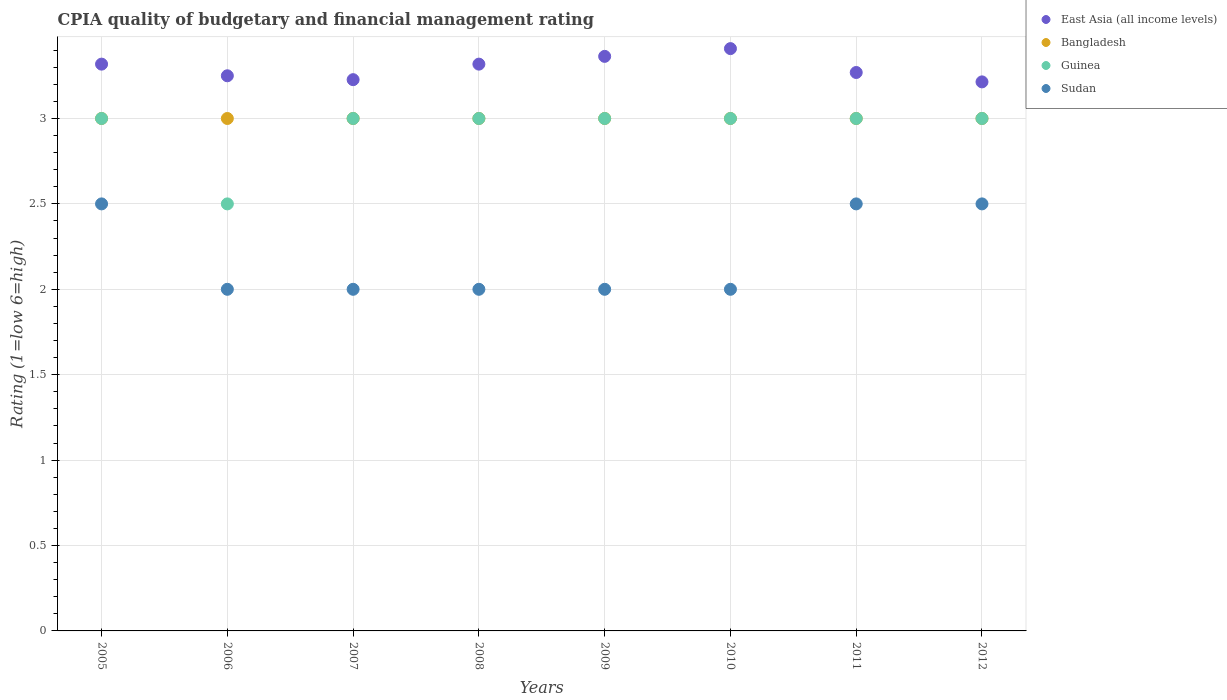How many different coloured dotlines are there?
Keep it short and to the point. 4. Is the number of dotlines equal to the number of legend labels?
Offer a terse response. Yes. What is the CPIA rating in Sudan in 2012?
Ensure brevity in your answer.  2.5. Across all years, what is the maximum CPIA rating in Bangladesh?
Ensure brevity in your answer.  3. Across all years, what is the minimum CPIA rating in Guinea?
Offer a terse response. 2.5. What is the difference between the CPIA rating in East Asia (all income levels) in 2005 and that in 2008?
Give a very brief answer. 0. What is the average CPIA rating in Guinea per year?
Make the answer very short. 2.94. In the year 2007, what is the difference between the CPIA rating in Bangladesh and CPIA rating in East Asia (all income levels)?
Your answer should be very brief. -0.23. What is the ratio of the CPIA rating in Bangladesh in 2007 to that in 2011?
Keep it short and to the point. 1. Is the difference between the CPIA rating in Bangladesh in 2005 and 2007 greater than the difference between the CPIA rating in East Asia (all income levels) in 2005 and 2007?
Your answer should be compact. No. What is the difference between the highest and the lowest CPIA rating in East Asia (all income levels)?
Your answer should be very brief. 0.19. In how many years, is the CPIA rating in Guinea greater than the average CPIA rating in Guinea taken over all years?
Give a very brief answer. 7. Is the sum of the CPIA rating in Sudan in 2007 and 2008 greater than the maximum CPIA rating in Bangladesh across all years?
Your response must be concise. Yes. Is it the case that in every year, the sum of the CPIA rating in Sudan and CPIA rating in East Asia (all income levels)  is greater than the sum of CPIA rating in Bangladesh and CPIA rating in Guinea?
Offer a terse response. No. Is it the case that in every year, the sum of the CPIA rating in East Asia (all income levels) and CPIA rating in Sudan  is greater than the CPIA rating in Guinea?
Keep it short and to the point. Yes. Does the graph contain grids?
Ensure brevity in your answer.  Yes. Where does the legend appear in the graph?
Your response must be concise. Top right. How many legend labels are there?
Your response must be concise. 4. What is the title of the graph?
Keep it short and to the point. CPIA quality of budgetary and financial management rating. Does "Cameroon" appear as one of the legend labels in the graph?
Make the answer very short. No. What is the Rating (1=low 6=high) in East Asia (all income levels) in 2005?
Make the answer very short. 3.32. What is the Rating (1=low 6=high) of Bangladesh in 2005?
Give a very brief answer. 3. What is the Rating (1=low 6=high) of Guinea in 2005?
Offer a terse response. 3. What is the Rating (1=low 6=high) in Bangladesh in 2006?
Provide a succinct answer. 3. What is the Rating (1=low 6=high) of Guinea in 2006?
Make the answer very short. 2.5. What is the Rating (1=low 6=high) in Sudan in 2006?
Your response must be concise. 2. What is the Rating (1=low 6=high) in East Asia (all income levels) in 2007?
Offer a terse response. 3.23. What is the Rating (1=low 6=high) in Bangladesh in 2007?
Make the answer very short. 3. What is the Rating (1=low 6=high) in East Asia (all income levels) in 2008?
Offer a terse response. 3.32. What is the Rating (1=low 6=high) of Bangladesh in 2008?
Give a very brief answer. 3. What is the Rating (1=low 6=high) of East Asia (all income levels) in 2009?
Your answer should be very brief. 3.36. What is the Rating (1=low 6=high) in Guinea in 2009?
Provide a short and direct response. 3. What is the Rating (1=low 6=high) in Sudan in 2009?
Your answer should be very brief. 2. What is the Rating (1=low 6=high) of East Asia (all income levels) in 2010?
Make the answer very short. 3.41. What is the Rating (1=low 6=high) in Guinea in 2010?
Provide a short and direct response. 3. What is the Rating (1=low 6=high) of East Asia (all income levels) in 2011?
Offer a very short reply. 3.27. What is the Rating (1=low 6=high) of East Asia (all income levels) in 2012?
Make the answer very short. 3.21. What is the Rating (1=low 6=high) in Guinea in 2012?
Your response must be concise. 3. Across all years, what is the maximum Rating (1=low 6=high) of East Asia (all income levels)?
Offer a terse response. 3.41. Across all years, what is the maximum Rating (1=low 6=high) in Sudan?
Your response must be concise. 2.5. Across all years, what is the minimum Rating (1=low 6=high) in East Asia (all income levels)?
Ensure brevity in your answer.  3.21. Across all years, what is the minimum Rating (1=low 6=high) in Bangladesh?
Your answer should be very brief. 3. Across all years, what is the minimum Rating (1=low 6=high) of Guinea?
Make the answer very short. 2.5. What is the total Rating (1=low 6=high) in East Asia (all income levels) in the graph?
Make the answer very short. 26.37. What is the total Rating (1=low 6=high) in Guinea in the graph?
Offer a very short reply. 23.5. What is the total Rating (1=low 6=high) in Sudan in the graph?
Offer a very short reply. 17.5. What is the difference between the Rating (1=low 6=high) of East Asia (all income levels) in 2005 and that in 2006?
Offer a terse response. 0.07. What is the difference between the Rating (1=low 6=high) in East Asia (all income levels) in 2005 and that in 2007?
Your answer should be very brief. 0.09. What is the difference between the Rating (1=low 6=high) of Bangladesh in 2005 and that in 2007?
Make the answer very short. 0. What is the difference between the Rating (1=low 6=high) of Sudan in 2005 and that in 2007?
Provide a succinct answer. 0.5. What is the difference between the Rating (1=low 6=high) of East Asia (all income levels) in 2005 and that in 2008?
Your answer should be very brief. 0. What is the difference between the Rating (1=low 6=high) in Sudan in 2005 and that in 2008?
Your response must be concise. 0.5. What is the difference between the Rating (1=low 6=high) of East Asia (all income levels) in 2005 and that in 2009?
Make the answer very short. -0.05. What is the difference between the Rating (1=low 6=high) in Sudan in 2005 and that in 2009?
Give a very brief answer. 0.5. What is the difference between the Rating (1=low 6=high) of East Asia (all income levels) in 2005 and that in 2010?
Offer a very short reply. -0.09. What is the difference between the Rating (1=low 6=high) of Bangladesh in 2005 and that in 2010?
Your answer should be very brief. 0. What is the difference between the Rating (1=low 6=high) of Guinea in 2005 and that in 2010?
Offer a very short reply. 0. What is the difference between the Rating (1=low 6=high) in Sudan in 2005 and that in 2010?
Offer a terse response. 0.5. What is the difference between the Rating (1=low 6=high) in East Asia (all income levels) in 2005 and that in 2011?
Your answer should be compact. 0.05. What is the difference between the Rating (1=low 6=high) of Guinea in 2005 and that in 2011?
Give a very brief answer. 0. What is the difference between the Rating (1=low 6=high) of East Asia (all income levels) in 2005 and that in 2012?
Your response must be concise. 0.1. What is the difference between the Rating (1=low 6=high) in Guinea in 2005 and that in 2012?
Make the answer very short. 0. What is the difference between the Rating (1=low 6=high) in Sudan in 2005 and that in 2012?
Offer a terse response. 0. What is the difference between the Rating (1=low 6=high) in East Asia (all income levels) in 2006 and that in 2007?
Keep it short and to the point. 0.02. What is the difference between the Rating (1=low 6=high) in Guinea in 2006 and that in 2007?
Provide a short and direct response. -0.5. What is the difference between the Rating (1=low 6=high) in East Asia (all income levels) in 2006 and that in 2008?
Give a very brief answer. -0.07. What is the difference between the Rating (1=low 6=high) of Bangladesh in 2006 and that in 2008?
Give a very brief answer. 0. What is the difference between the Rating (1=low 6=high) of Guinea in 2006 and that in 2008?
Provide a short and direct response. -0.5. What is the difference between the Rating (1=low 6=high) in East Asia (all income levels) in 2006 and that in 2009?
Offer a terse response. -0.11. What is the difference between the Rating (1=low 6=high) of Guinea in 2006 and that in 2009?
Provide a short and direct response. -0.5. What is the difference between the Rating (1=low 6=high) in East Asia (all income levels) in 2006 and that in 2010?
Ensure brevity in your answer.  -0.16. What is the difference between the Rating (1=low 6=high) of Bangladesh in 2006 and that in 2010?
Provide a short and direct response. 0. What is the difference between the Rating (1=low 6=high) in Guinea in 2006 and that in 2010?
Offer a terse response. -0.5. What is the difference between the Rating (1=low 6=high) in Sudan in 2006 and that in 2010?
Your answer should be compact. 0. What is the difference between the Rating (1=low 6=high) of East Asia (all income levels) in 2006 and that in 2011?
Provide a succinct answer. -0.02. What is the difference between the Rating (1=low 6=high) in Guinea in 2006 and that in 2011?
Provide a short and direct response. -0.5. What is the difference between the Rating (1=low 6=high) in East Asia (all income levels) in 2006 and that in 2012?
Provide a succinct answer. 0.04. What is the difference between the Rating (1=low 6=high) of Bangladesh in 2006 and that in 2012?
Your answer should be very brief. 0. What is the difference between the Rating (1=low 6=high) of Guinea in 2006 and that in 2012?
Provide a short and direct response. -0.5. What is the difference between the Rating (1=low 6=high) of Sudan in 2006 and that in 2012?
Give a very brief answer. -0.5. What is the difference between the Rating (1=low 6=high) of East Asia (all income levels) in 2007 and that in 2008?
Provide a short and direct response. -0.09. What is the difference between the Rating (1=low 6=high) in Bangladesh in 2007 and that in 2008?
Offer a terse response. 0. What is the difference between the Rating (1=low 6=high) in Sudan in 2007 and that in 2008?
Your answer should be compact. 0. What is the difference between the Rating (1=low 6=high) of East Asia (all income levels) in 2007 and that in 2009?
Make the answer very short. -0.14. What is the difference between the Rating (1=low 6=high) in Bangladesh in 2007 and that in 2009?
Your answer should be compact. 0. What is the difference between the Rating (1=low 6=high) of East Asia (all income levels) in 2007 and that in 2010?
Offer a very short reply. -0.18. What is the difference between the Rating (1=low 6=high) of Sudan in 2007 and that in 2010?
Ensure brevity in your answer.  0. What is the difference between the Rating (1=low 6=high) of East Asia (all income levels) in 2007 and that in 2011?
Provide a succinct answer. -0.04. What is the difference between the Rating (1=low 6=high) in Guinea in 2007 and that in 2011?
Your answer should be compact. 0. What is the difference between the Rating (1=low 6=high) of Sudan in 2007 and that in 2011?
Make the answer very short. -0.5. What is the difference between the Rating (1=low 6=high) in East Asia (all income levels) in 2007 and that in 2012?
Your response must be concise. 0.01. What is the difference between the Rating (1=low 6=high) of Bangladesh in 2007 and that in 2012?
Keep it short and to the point. 0. What is the difference between the Rating (1=low 6=high) in East Asia (all income levels) in 2008 and that in 2009?
Your response must be concise. -0.05. What is the difference between the Rating (1=low 6=high) in Bangladesh in 2008 and that in 2009?
Your answer should be compact. 0. What is the difference between the Rating (1=low 6=high) of East Asia (all income levels) in 2008 and that in 2010?
Your answer should be compact. -0.09. What is the difference between the Rating (1=low 6=high) in Guinea in 2008 and that in 2010?
Keep it short and to the point. 0. What is the difference between the Rating (1=low 6=high) of Sudan in 2008 and that in 2010?
Offer a terse response. 0. What is the difference between the Rating (1=low 6=high) in East Asia (all income levels) in 2008 and that in 2011?
Offer a very short reply. 0.05. What is the difference between the Rating (1=low 6=high) of Bangladesh in 2008 and that in 2011?
Offer a terse response. 0. What is the difference between the Rating (1=low 6=high) in Sudan in 2008 and that in 2011?
Your answer should be compact. -0.5. What is the difference between the Rating (1=low 6=high) of East Asia (all income levels) in 2008 and that in 2012?
Your answer should be compact. 0.1. What is the difference between the Rating (1=low 6=high) in East Asia (all income levels) in 2009 and that in 2010?
Make the answer very short. -0.05. What is the difference between the Rating (1=low 6=high) of Guinea in 2009 and that in 2010?
Make the answer very short. 0. What is the difference between the Rating (1=low 6=high) in Sudan in 2009 and that in 2010?
Provide a succinct answer. 0. What is the difference between the Rating (1=low 6=high) of East Asia (all income levels) in 2009 and that in 2011?
Provide a succinct answer. 0.09. What is the difference between the Rating (1=low 6=high) of Bangladesh in 2009 and that in 2011?
Offer a very short reply. 0. What is the difference between the Rating (1=low 6=high) in East Asia (all income levels) in 2009 and that in 2012?
Provide a succinct answer. 0.15. What is the difference between the Rating (1=low 6=high) in Bangladesh in 2009 and that in 2012?
Offer a terse response. 0. What is the difference between the Rating (1=low 6=high) in Sudan in 2009 and that in 2012?
Provide a succinct answer. -0.5. What is the difference between the Rating (1=low 6=high) in East Asia (all income levels) in 2010 and that in 2011?
Ensure brevity in your answer.  0.14. What is the difference between the Rating (1=low 6=high) of Bangladesh in 2010 and that in 2011?
Ensure brevity in your answer.  0. What is the difference between the Rating (1=low 6=high) in Guinea in 2010 and that in 2011?
Provide a succinct answer. 0. What is the difference between the Rating (1=low 6=high) of East Asia (all income levels) in 2010 and that in 2012?
Offer a very short reply. 0.19. What is the difference between the Rating (1=low 6=high) in Bangladesh in 2010 and that in 2012?
Provide a short and direct response. 0. What is the difference between the Rating (1=low 6=high) of Guinea in 2010 and that in 2012?
Your response must be concise. 0. What is the difference between the Rating (1=low 6=high) in Sudan in 2010 and that in 2012?
Your response must be concise. -0.5. What is the difference between the Rating (1=low 6=high) of East Asia (all income levels) in 2011 and that in 2012?
Make the answer very short. 0.05. What is the difference between the Rating (1=low 6=high) of Guinea in 2011 and that in 2012?
Give a very brief answer. 0. What is the difference between the Rating (1=low 6=high) in East Asia (all income levels) in 2005 and the Rating (1=low 6=high) in Bangladesh in 2006?
Provide a succinct answer. 0.32. What is the difference between the Rating (1=low 6=high) of East Asia (all income levels) in 2005 and the Rating (1=low 6=high) of Guinea in 2006?
Your answer should be very brief. 0.82. What is the difference between the Rating (1=low 6=high) in East Asia (all income levels) in 2005 and the Rating (1=low 6=high) in Sudan in 2006?
Make the answer very short. 1.32. What is the difference between the Rating (1=low 6=high) of Bangladesh in 2005 and the Rating (1=low 6=high) of Sudan in 2006?
Give a very brief answer. 1. What is the difference between the Rating (1=low 6=high) of Guinea in 2005 and the Rating (1=low 6=high) of Sudan in 2006?
Provide a succinct answer. 1. What is the difference between the Rating (1=low 6=high) in East Asia (all income levels) in 2005 and the Rating (1=low 6=high) in Bangladesh in 2007?
Keep it short and to the point. 0.32. What is the difference between the Rating (1=low 6=high) of East Asia (all income levels) in 2005 and the Rating (1=low 6=high) of Guinea in 2007?
Provide a succinct answer. 0.32. What is the difference between the Rating (1=low 6=high) in East Asia (all income levels) in 2005 and the Rating (1=low 6=high) in Sudan in 2007?
Your answer should be very brief. 1.32. What is the difference between the Rating (1=low 6=high) of Bangladesh in 2005 and the Rating (1=low 6=high) of Guinea in 2007?
Provide a succinct answer. 0. What is the difference between the Rating (1=low 6=high) of Guinea in 2005 and the Rating (1=low 6=high) of Sudan in 2007?
Ensure brevity in your answer.  1. What is the difference between the Rating (1=low 6=high) in East Asia (all income levels) in 2005 and the Rating (1=low 6=high) in Bangladesh in 2008?
Ensure brevity in your answer.  0.32. What is the difference between the Rating (1=low 6=high) of East Asia (all income levels) in 2005 and the Rating (1=low 6=high) of Guinea in 2008?
Give a very brief answer. 0.32. What is the difference between the Rating (1=low 6=high) of East Asia (all income levels) in 2005 and the Rating (1=low 6=high) of Sudan in 2008?
Give a very brief answer. 1.32. What is the difference between the Rating (1=low 6=high) in Bangladesh in 2005 and the Rating (1=low 6=high) in Sudan in 2008?
Keep it short and to the point. 1. What is the difference between the Rating (1=low 6=high) of East Asia (all income levels) in 2005 and the Rating (1=low 6=high) of Bangladesh in 2009?
Ensure brevity in your answer.  0.32. What is the difference between the Rating (1=low 6=high) of East Asia (all income levels) in 2005 and the Rating (1=low 6=high) of Guinea in 2009?
Your answer should be very brief. 0.32. What is the difference between the Rating (1=low 6=high) in East Asia (all income levels) in 2005 and the Rating (1=low 6=high) in Sudan in 2009?
Your response must be concise. 1.32. What is the difference between the Rating (1=low 6=high) in Bangladesh in 2005 and the Rating (1=low 6=high) in Guinea in 2009?
Make the answer very short. 0. What is the difference between the Rating (1=low 6=high) in Bangladesh in 2005 and the Rating (1=low 6=high) in Sudan in 2009?
Your answer should be very brief. 1. What is the difference between the Rating (1=low 6=high) of East Asia (all income levels) in 2005 and the Rating (1=low 6=high) of Bangladesh in 2010?
Your response must be concise. 0.32. What is the difference between the Rating (1=low 6=high) of East Asia (all income levels) in 2005 and the Rating (1=low 6=high) of Guinea in 2010?
Offer a terse response. 0.32. What is the difference between the Rating (1=low 6=high) of East Asia (all income levels) in 2005 and the Rating (1=low 6=high) of Sudan in 2010?
Provide a short and direct response. 1.32. What is the difference between the Rating (1=low 6=high) of Bangladesh in 2005 and the Rating (1=low 6=high) of Guinea in 2010?
Ensure brevity in your answer.  0. What is the difference between the Rating (1=low 6=high) of Bangladesh in 2005 and the Rating (1=low 6=high) of Sudan in 2010?
Your answer should be very brief. 1. What is the difference between the Rating (1=low 6=high) in East Asia (all income levels) in 2005 and the Rating (1=low 6=high) in Bangladesh in 2011?
Provide a short and direct response. 0.32. What is the difference between the Rating (1=low 6=high) of East Asia (all income levels) in 2005 and the Rating (1=low 6=high) of Guinea in 2011?
Your response must be concise. 0.32. What is the difference between the Rating (1=low 6=high) of East Asia (all income levels) in 2005 and the Rating (1=low 6=high) of Sudan in 2011?
Make the answer very short. 0.82. What is the difference between the Rating (1=low 6=high) of Bangladesh in 2005 and the Rating (1=low 6=high) of Sudan in 2011?
Offer a very short reply. 0.5. What is the difference between the Rating (1=low 6=high) in East Asia (all income levels) in 2005 and the Rating (1=low 6=high) in Bangladesh in 2012?
Offer a terse response. 0.32. What is the difference between the Rating (1=low 6=high) in East Asia (all income levels) in 2005 and the Rating (1=low 6=high) in Guinea in 2012?
Provide a short and direct response. 0.32. What is the difference between the Rating (1=low 6=high) of East Asia (all income levels) in 2005 and the Rating (1=low 6=high) of Sudan in 2012?
Provide a succinct answer. 0.82. What is the difference between the Rating (1=low 6=high) of Bangladesh in 2005 and the Rating (1=low 6=high) of Sudan in 2012?
Your answer should be compact. 0.5. What is the difference between the Rating (1=low 6=high) in East Asia (all income levels) in 2006 and the Rating (1=low 6=high) in Bangladesh in 2007?
Your response must be concise. 0.25. What is the difference between the Rating (1=low 6=high) of East Asia (all income levels) in 2006 and the Rating (1=low 6=high) of Guinea in 2007?
Offer a terse response. 0.25. What is the difference between the Rating (1=low 6=high) of East Asia (all income levels) in 2006 and the Rating (1=low 6=high) of Sudan in 2007?
Keep it short and to the point. 1.25. What is the difference between the Rating (1=low 6=high) of Bangladesh in 2006 and the Rating (1=low 6=high) of Guinea in 2007?
Give a very brief answer. 0. What is the difference between the Rating (1=low 6=high) of East Asia (all income levels) in 2006 and the Rating (1=low 6=high) of Bangladesh in 2008?
Provide a succinct answer. 0.25. What is the difference between the Rating (1=low 6=high) of East Asia (all income levels) in 2006 and the Rating (1=low 6=high) of Guinea in 2008?
Offer a very short reply. 0.25. What is the difference between the Rating (1=low 6=high) in East Asia (all income levels) in 2006 and the Rating (1=low 6=high) in Sudan in 2008?
Make the answer very short. 1.25. What is the difference between the Rating (1=low 6=high) of Bangladesh in 2006 and the Rating (1=low 6=high) of Guinea in 2008?
Your answer should be compact. 0. What is the difference between the Rating (1=low 6=high) in Bangladesh in 2006 and the Rating (1=low 6=high) in Sudan in 2008?
Offer a terse response. 1. What is the difference between the Rating (1=low 6=high) of Guinea in 2006 and the Rating (1=low 6=high) of Sudan in 2008?
Make the answer very short. 0.5. What is the difference between the Rating (1=low 6=high) of East Asia (all income levels) in 2006 and the Rating (1=low 6=high) of Bangladesh in 2009?
Give a very brief answer. 0.25. What is the difference between the Rating (1=low 6=high) in East Asia (all income levels) in 2006 and the Rating (1=low 6=high) in Guinea in 2009?
Your answer should be very brief. 0.25. What is the difference between the Rating (1=low 6=high) of Bangladesh in 2006 and the Rating (1=low 6=high) of Sudan in 2009?
Provide a succinct answer. 1. What is the difference between the Rating (1=low 6=high) of Guinea in 2006 and the Rating (1=low 6=high) of Sudan in 2009?
Ensure brevity in your answer.  0.5. What is the difference between the Rating (1=low 6=high) of East Asia (all income levels) in 2006 and the Rating (1=low 6=high) of Guinea in 2010?
Your answer should be compact. 0.25. What is the difference between the Rating (1=low 6=high) in Bangladesh in 2006 and the Rating (1=low 6=high) in Guinea in 2010?
Give a very brief answer. 0. What is the difference between the Rating (1=low 6=high) in Bangladesh in 2006 and the Rating (1=low 6=high) in Sudan in 2010?
Give a very brief answer. 1. What is the difference between the Rating (1=low 6=high) of Guinea in 2006 and the Rating (1=low 6=high) of Sudan in 2010?
Your answer should be very brief. 0.5. What is the difference between the Rating (1=low 6=high) of East Asia (all income levels) in 2006 and the Rating (1=low 6=high) of Bangladesh in 2011?
Your answer should be very brief. 0.25. What is the difference between the Rating (1=low 6=high) of Bangladesh in 2006 and the Rating (1=low 6=high) of Sudan in 2011?
Give a very brief answer. 0.5. What is the difference between the Rating (1=low 6=high) in Guinea in 2006 and the Rating (1=low 6=high) in Sudan in 2011?
Offer a terse response. 0. What is the difference between the Rating (1=low 6=high) in East Asia (all income levels) in 2006 and the Rating (1=low 6=high) in Guinea in 2012?
Your answer should be compact. 0.25. What is the difference between the Rating (1=low 6=high) in Bangladesh in 2006 and the Rating (1=low 6=high) in Guinea in 2012?
Make the answer very short. 0. What is the difference between the Rating (1=low 6=high) in Bangladesh in 2006 and the Rating (1=low 6=high) in Sudan in 2012?
Provide a short and direct response. 0.5. What is the difference between the Rating (1=low 6=high) in East Asia (all income levels) in 2007 and the Rating (1=low 6=high) in Bangladesh in 2008?
Offer a very short reply. 0.23. What is the difference between the Rating (1=low 6=high) of East Asia (all income levels) in 2007 and the Rating (1=low 6=high) of Guinea in 2008?
Make the answer very short. 0.23. What is the difference between the Rating (1=low 6=high) in East Asia (all income levels) in 2007 and the Rating (1=low 6=high) in Sudan in 2008?
Keep it short and to the point. 1.23. What is the difference between the Rating (1=low 6=high) in Bangladesh in 2007 and the Rating (1=low 6=high) in Guinea in 2008?
Offer a terse response. 0. What is the difference between the Rating (1=low 6=high) of Guinea in 2007 and the Rating (1=low 6=high) of Sudan in 2008?
Ensure brevity in your answer.  1. What is the difference between the Rating (1=low 6=high) of East Asia (all income levels) in 2007 and the Rating (1=low 6=high) of Bangladesh in 2009?
Your answer should be very brief. 0.23. What is the difference between the Rating (1=low 6=high) of East Asia (all income levels) in 2007 and the Rating (1=low 6=high) of Guinea in 2009?
Provide a short and direct response. 0.23. What is the difference between the Rating (1=low 6=high) of East Asia (all income levels) in 2007 and the Rating (1=low 6=high) of Sudan in 2009?
Provide a short and direct response. 1.23. What is the difference between the Rating (1=low 6=high) of Bangladesh in 2007 and the Rating (1=low 6=high) of Guinea in 2009?
Provide a short and direct response. 0. What is the difference between the Rating (1=low 6=high) of Guinea in 2007 and the Rating (1=low 6=high) of Sudan in 2009?
Your answer should be compact. 1. What is the difference between the Rating (1=low 6=high) in East Asia (all income levels) in 2007 and the Rating (1=low 6=high) in Bangladesh in 2010?
Provide a succinct answer. 0.23. What is the difference between the Rating (1=low 6=high) of East Asia (all income levels) in 2007 and the Rating (1=low 6=high) of Guinea in 2010?
Keep it short and to the point. 0.23. What is the difference between the Rating (1=low 6=high) in East Asia (all income levels) in 2007 and the Rating (1=low 6=high) in Sudan in 2010?
Provide a short and direct response. 1.23. What is the difference between the Rating (1=low 6=high) in Guinea in 2007 and the Rating (1=low 6=high) in Sudan in 2010?
Give a very brief answer. 1. What is the difference between the Rating (1=low 6=high) in East Asia (all income levels) in 2007 and the Rating (1=low 6=high) in Bangladesh in 2011?
Your response must be concise. 0.23. What is the difference between the Rating (1=low 6=high) of East Asia (all income levels) in 2007 and the Rating (1=low 6=high) of Guinea in 2011?
Make the answer very short. 0.23. What is the difference between the Rating (1=low 6=high) in East Asia (all income levels) in 2007 and the Rating (1=low 6=high) in Sudan in 2011?
Your answer should be compact. 0.73. What is the difference between the Rating (1=low 6=high) in East Asia (all income levels) in 2007 and the Rating (1=low 6=high) in Bangladesh in 2012?
Your response must be concise. 0.23. What is the difference between the Rating (1=low 6=high) of East Asia (all income levels) in 2007 and the Rating (1=low 6=high) of Guinea in 2012?
Provide a short and direct response. 0.23. What is the difference between the Rating (1=low 6=high) in East Asia (all income levels) in 2007 and the Rating (1=low 6=high) in Sudan in 2012?
Give a very brief answer. 0.73. What is the difference between the Rating (1=low 6=high) of Bangladesh in 2007 and the Rating (1=low 6=high) of Guinea in 2012?
Give a very brief answer. 0. What is the difference between the Rating (1=low 6=high) of Bangladesh in 2007 and the Rating (1=low 6=high) of Sudan in 2012?
Give a very brief answer. 0.5. What is the difference between the Rating (1=low 6=high) in Guinea in 2007 and the Rating (1=low 6=high) in Sudan in 2012?
Your answer should be very brief. 0.5. What is the difference between the Rating (1=low 6=high) of East Asia (all income levels) in 2008 and the Rating (1=low 6=high) of Bangladesh in 2009?
Make the answer very short. 0.32. What is the difference between the Rating (1=low 6=high) in East Asia (all income levels) in 2008 and the Rating (1=low 6=high) in Guinea in 2009?
Make the answer very short. 0.32. What is the difference between the Rating (1=low 6=high) in East Asia (all income levels) in 2008 and the Rating (1=low 6=high) in Sudan in 2009?
Your answer should be compact. 1.32. What is the difference between the Rating (1=low 6=high) in Bangladesh in 2008 and the Rating (1=low 6=high) in Guinea in 2009?
Ensure brevity in your answer.  0. What is the difference between the Rating (1=low 6=high) of Bangladesh in 2008 and the Rating (1=low 6=high) of Sudan in 2009?
Offer a terse response. 1. What is the difference between the Rating (1=low 6=high) in Guinea in 2008 and the Rating (1=low 6=high) in Sudan in 2009?
Offer a terse response. 1. What is the difference between the Rating (1=low 6=high) in East Asia (all income levels) in 2008 and the Rating (1=low 6=high) in Bangladesh in 2010?
Offer a terse response. 0.32. What is the difference between the Rating (1=low 6=high) in East Asia (all income levels) in 2008 and the Rating (1=low 6=high) in Guinea in 2010?
Keep it short and to the point. 0.32. What is the difference between the Rating (1=low 6=high) in East Asia (all income levels) in 2008 and the Rating (1=low 6=high) in Sudan in 2010?
Give a very brief answer. 1.32. What is the difference between the Rating (1=low 6=high) of Bangladesh in 2008 and the Rating (1=low 6=high) of Sudan in 2010?
Offer a terse response. 1. What is the difference between the Rating (1=low 6=high) of Guinea in 2008 and the Rating (1=low 6=high) of Sudan in 2010?
Ensure brevity in your answer.  1. What is the difference between the Rating (1=low 6=high) of East Asia (all income levels) in 2008 and the Rating (1=low 6=high) of Bangladesh in 2011?
Provide a succinct answer. 0.32. What is the difference between the Rating (1=low 6=high) of East Asia (all income levels) in 2008 and the Rating (1=low 6=high) of Guinea in 2011?
Your answer should be very brief. 0.32. What is the difference between the Rating (1=low 6=high) of East Asia (all income levels) in 2008 and the Rating (1=low 6=high) of Sudan in 2011?
Offer a very short reply. 0.82. What is the difference between the Rating (1=low 6=high) in Bangladesh in 2008 and the Rating (1=low 6=high) in Guinea in 2011?
Make the answer very short. 0. What is the difference between the Rating (1=low 6=high) in Guinea in 2008 and the Rating (1=low 6=high) in Sudan in 2011?
Keep it short and to the point. 0.5. What is the difference between the Rating (1=low 6=high) in East Asia (all income levels) in 2008 and the Rating (1=low 6=high) in Bangladesh in 2012?
Offer a very short reply. 0.32. What is the difference between the Rating (1=low 6=high) of East Asia (all income levels) in 2008 and the Rating (1=low 6=high) of Guinea in 2012?
Your answer should be compact. 0.32. What is the difference between the Rating (1=low 6=high) of East Asia (all income levels) in 2008 and the Rating (1=low 6=high) of Sudan in 2012?
Your answer should be compact. 0.82. What is the difference between the Rating (1=low 6=high) in East Asia (all income levels) in 2009 and the Rating (1=low 6=high) in Bangladesh in 2010?
Offer a terse response. 0.36. What is the difference between the Rating (1=low 6=high) in East Asia (all income levels) in 2009 and the Rating (1=low 6=high) in Guinea in 2010?
Offer a very short reply. 0.36. What is the difference between the Rating (1=low 6=high) of East Asia (all income levels) in 2009 and the Rating (1=low 6=high) of Sudan in 2010?
Ensure brevity in your answer.  1.36. What is the difference between the Rating (1=low 6=high) of Bangladesh in 2009 and the Rating (1=low 6=high) of Sudan in 2010?
Make the answer very short. 1. What is the difference between the Rating (1=low 6=high) of East Asia (all income levels) in 2009 and the Rating (1=low 6=high) of Bangladesh in 2011?
Provide a succinct answer. 0.36. What is the difference between the Rating (1=low 6=high) in East Asia (all income levels) in 2009 and the Rating (1=low 6=high) in Guinea in 2011?
Offer a terse response. 0.36. What is the difference between the Rating (1=low 6=high) of East Asia (all income levels) in 2009 and the Rating (1=low 6=high) of Sudan in 2011?
Keep it short and to the point. 0.86. What is the difference between the Rating (1=low 6=high) of Bangladesh in 2009 and the Rating (1=low 6=high) of Sudan in 2011?
Your response must be concise. 0.5. What is the difference between the Rating (1=low 6=high) in East Asia (all income levels) in 2009 and the Rating (1=low 6=high) in Bangladesh in 2012?
Offer a very short reply. 0.36. What is the difference between the Rating (1=low 6=high) of East Asia (all income levels) in 2009 and the Rating (1=low 6=high) of Guinea in 2012?
Give a very brief answer. 0.36. What is the difference between the Rating (1=low 6=high) of East Asia (all income levels) in 2009 and the Rating (1=low 6=high) of Sudan in 2012?
Ensure brevity in your answer.  0.86. What is the difference between the Rating (1=low 6=high) of Bangladesh in 2009 and the Rating (1=low 6=high) of Sudan in 2012?
Your answer should be very brief. 0.5. What is the difference between the Rating (1=low 6=high) in Guinea in 2009 and the Rating (1=low 6=high) in Sudan in 2012?
Ensure brevity in your answer.  0.5. What is the difference between the Rating (1=low 6=high) in East Asia (all income levels) in 2010 and the Rating (1=low 6=high) in Bangladesh in 2011?
Provide a short and direct response. 0.41. What is the difference between the Rating (1=low 6=high) in East Asia (all income levels) in 2010 and the Rating (1=low 6=high) in Guinea in 2011?
Your answer should be very brief. 0.41. What is the difference between the Rating (1=low 6=high) of East Asia (all income levels) in 2010 and the Rating (1=low 6=high) of Bangladesh in 2012?
Your answer should be compact. 0.41. What is the difference between the Rating (1=low 6=high) in East Asia (all income levels) in 2010 and the Rating (1=low 6=high) in Guinea in 2012?
Give a very brief answer. 0.41. What is the difference between the Rating (1=low 6=high) in Bangladesh in 2010 and the Rating (1=low 6=high) in Guinea in 2012?
Offer a terse response. 0. What is the difference between the Rating (1=low 6=high) of Bangladesh in 2010 and the Rating (1=low 6=high) of Sudan in 2012?
Provide a succinct answer. 0.5. What is the difference between the Rating (1=low 6=high) in East Asia (all income levels) in 2011 and the Rating (1=low 6=high) in Bangladesh in 2012?
Ensure brevity in your answer.  0.27. What is the difference between the Rating (1=low 6=high) in East Asia (all income levels) in 2011 and the Rating (1=low 6=high) in Guinea in 2012?
Make the answer very short. 0.27. What is the difference between the Rating (1=low 6=high) in East Asia (all income levels) in 2011 and the Rating (1=low 6=high) in Sudan in 2012?
Make the answer very short. 0.77. What is the difference between the Rating (1=low 6=high) of Bangladesh in 2011 and the Rating (1=low 6=high) of Guinea in 2012?
Offer a very short reply. 0. What is the difference between the Rating (1=low 6=high) of Guinea in 2011 and the Rating (1=low 6=high) of Sudan in 2012?
Your answer should be very brief. 0.5. What is the average Rating (1=low 6=high) of East Asia (all income levels) per year?
Your answer should be compact. 3.3. What is the average Rating (1=low 6=high) in Guinea per year?
Your response must be concise. 2.94. What is the average Rating (1=low 6=high) of Sudan per year?
Keep it short and to the point. 2.19. In the year 2005, what is the difference between the Rating (1=low 6=high) in East Asia (all income levels) and Rating (1=low 6=high) in Bangladesh?
Your response must be concise. 0.32. In the year 2005, what is the difference between the Rating (1=low 6=high) of East Asia (all income levels) and Rating (1=low 6=high) of Guinea?
Make the answer very short. 0.32. In the year 2005, what is the difference between the Rating (1=low 6=high) of East Asia (all income levels) and Rating (1=low 6=high) of Sudan?
Offer a terse response. 0.82. In the year 2005, what is the difference between the Rating (1=low 6=high) in Bangladesh and Rating (1=low 6=high) in Sudan?
Ensure brevity in your answer.  0.5. In the year 2005, what is the difference between the Rating (1=low 6=high) in Guinea and Rating (1=low 6=high) in Sudan?
Offer a terse response. 0.5. In the year 2006, what is the difference between the Rating (1=low 6=high) in East Asia (all income levels) and Rating (1=low 6=high) in Bangladesh?
Provide a succinct answer. 0.25. In the year 2006, what is the difference between the Rating (1=low 6=high) in East Asia (all income levels) and Rating (1=low 6=high) in Guinea?
Provide a short and direct response. 0.75. In the year 2006, what is the difference between the Rating (1=low 6=high) of East Asia (all income levels) and Rating (1=low 6=high) of Sudan?
Your response must be concise. 1.25. In the year 2006, what is the difference between the Rating (1=low 6=high) in Guinea and Rating (1=low 6=high) in Sudan?
Ensure brevity in your answer.  0.5. In the year 2007, what is the difference between the Rating (1=low 6=high) of East Asia (all income levels) and Rating (1=low 6=high) of Bangladesh?
Your response must be concise. 0.23. In the year 2007, what is the difference between the Rating (1=low 6=high) of East Asia (all income levels) and Rating (1=low 6=high) of Guinea?
Your answer should be compact. 0.23. In the year 2007, what is the difference between the Rating (1=low 6=high) of East Asia (all income levels) and Rating (1=low 6=high) of Sudan?
Offer a terse response. 1.23. In the year 2007, what is the difference between the Rating (1=low 6=high) of Bangladesh and Rating (1=low 6=high) of Guinea?
Offer a very short reply. 0. In the year 2007, what is the difference between the Rating (1=low 6=high) in Bangladesh and Rating (1=low 6=high) in Sudan?
Give a very brief answer. 1. In the year 2007, what is the difference between the Rating (1=low 6=high) in Guinea and Rating (1=low 6=high) in Sudan?
Give a very brief answer. 1. In the year 2008, what is the difference between the Rating (1=low 6=high) in East Asia (all income levels) and Rating (1=low 6=high) in Bangladesh?
Your answer should be compact. 0.32. In the year 2008, what is the difference between the Rating (1=low 6=high) of East Asia (all income levels) and Rating (1=low 6=high) of Guinea?
Offer a terse response. 0.32. In the year 2008, what is the difference between the Rating (1=low 6=high) in East Asia (all income levels) and Rating (1=low 6=high) in Sudan?
Your answer should be very brief. 1.32. In the year 2008, what is the difference between the Rating (1=low 6=high) of Guinea and Rating (1=low 6=high) of Sudan?
Provide a short and direct response. 1. In the year 2009, what is the difference between the Rating (1=low 6=high) in East Asia (all income levels) and Rating (1=low 6=high) in Bangladesh?
Make the answer very short. 0.36. In the year 2009, what is the difference between the Rating (1=low 6=high) of East Asia (all income levels) and Rating (1=low 6=high) of Guinea?
Provide a succinct answer. 0.36. In the year 2009, what is the difference between the Rating (1=low 6=high) in East Asia (all income levels) and Rating (1=low 6=high) in Sudan?
Make the answer very short. 1.36. In the year 2009, what is the difference between the Rating (1=low 6=high) in Bangladesh and Rating (1=low 6=high) in Guinea?
Give a very brief answer. 0. In the year 2009, what is the difference between the Rating (1=low 6=high) in Guinea and Rating (1=low 6=high) in Sudan?
Your answer should be compact. 1. In the year 2010, what is the difference between the Rating (1=low 6=high) in East Asia (all income levels) and Rating (1=low 6=high) in Bangladesh?
Your answer should be compact. 0.41. In the year 2010, what is the difference between the Rating (1=low 6=high) of East Asia (all income levels) and Rating (1=low 6=high) of Guinea?
Offer a very short reply. 0.41. In the year 2010, what is the difference between the Rating (1=low 6=high) of East Asia (all income levels) and Rating (1=low 6=high) of Sudan?
Your answer should be very brief. 1.41. In the year 2010, what is the difference between the Rating (1=low 6=high) in Bangladesh and Rating (1=low 6=high) in Guinea?
Offer a terse response. 0. In the year 2010, what is the difference between the Rating (1=low 6=high) of Bangladesh and Rating (1=low 6=high) of Sudan?
Make the answer very short. 1. In the year 2011, what is the difference between the Rating (1=low 6=high) in East Asia (all income levels) and Rating (1=low 6=high) in Bangladesh?
Keep it short and to the point. 0.27. In the year 2011, what is the difference between the Rating (1=low 6=high) in East Asia (all income levels) and Rating (1=low 6=high) in Guinea?
Keep it short and to the point. 0.27. In the year 2011, what is the difference between the Rating (1=low 6=high) in East Asia (all income levels) and Rating (1=low 6=high) in Sudan?
Your answer should be very brief. 0.77. In the year 2011, what is the difference between the Rating (1=low 6=high) in Bangladesh and Rating (1=low 6=high) in Guinea?
Offer a terse response. 0. In the year 2011, what is the difference between the Rating (1=low 6=high) of Guinea and Rating (1=low 6=high) of Sudan?
Your answer should be very brief. 0.5. In the year 2012, what is the difference between the Rating (1=low 6=high) of East Asia (all income levels) and Rating (1=low 6=high) of Bangladesh?
Make the answer very short. 0.21. In the year 2012, what is the difference between the Rating (1=low 6=high) in East Asia (all income levels) and Rating (1=low 6=high) in Guinea?
Offer a terse response. 0.21. In the year 2012, what is the difference between the Rating (1=low 6=high) of Bangladesh and Rating (1=low 6=high) of Sudan?
Give a very brief answer. 0.5. In the year 2012, what is the difference between the Rating (1=low 6=high) of Guinea and Rating (1=low 6=high) of Sudan?
Offer a very short reply. 0.5. What is the ratio of the Rating (1=low 6=high) in Bangladesh in 2005 to that in 2006?
Your response must be concise. 1. What is the ratio of the Rating (1=low 6=high) in Guinea in 2005 to that in 2006?
Keep it short and to the point. 1.2. What is the ratio of the Rating (1=low 6=high) of Sudan in 2005 to that in 2006?
Ensure brevity in your answer.  1.25. What is the ratio of the Rating (1=low 6=high) of East Asia (all income levels) in 2005 to that in 2007?
Offer a very short reply. 1.03. What is the ratio of the Rating (1=low 6=high) in Bangladesh in 2005 to that in 2007?
Keep it short and to the point. 1. What is the ratio of the Rating (1=low 6=high) in East Asia (all income levels) in 2005 to that in 2008?
Your response must be concise. 1. What is the ratio of the Rating (1=low 6=high) of Bangladesh in 2005 to that in 2008?
Provide a short and direct response. 1. What is the ratio of the Rating (1=low 6=high) in East Asia (all income levels) in 2005 to that in 2009?
Your response must be concise. 0.99. What is the ratio of the Rating (1=low 6=high) in Bangladesh in 2005 to that in 2009?
Your answer should be very brief. 1. What is the ratio of the Rating (1=low 6=high) in Sudan in 2005 to that in 2009?
Offer a terse response. 1.25. What is the ratio of the Rating (1=low 6=high) of East Asia (all income levels) in 2005 to that in 2010?
Your response must be concise. 0.97. What is the ratio of the Rating (1=low 6=high) of Bangladesh in 2005 to that in 2010?
Your answer should be very brief. 1. What is the ratio of the Rating (1=low 6=high) of Sudan in 2005 to that in 2010?
Your answer should be compact. 1.25. What is the ratio of the Rating (1=low 6=high) of East Asia (all income levels) in 2005 to that in 2011?
Your response must be concise. 1.01. What is the ratio of the Rating (1=low 6=high) in Guinea in 2005 to that in 2011?
Provide a short and direct response. 1. What is the ratio of the Rating (1=low 6=high) of East Asia (all income levels) in 2005 to that in 2012?
Offer a very short reply. 1.03. What is the ratio of the Rating (1=low 6=high) of Guinea in 2005 to that in 2012?
Your response must be concise. 1. What is the ratio of the Rating (1=low 6=high) of East Asia (all income levels) in 2006 to that in 2007?
Make the answer very short. 1.01. What is the ratio of the Rating (1=low 6=high) of Bangladesh in 2006 to that in 2007?
Your answer should be very brief. 1. What is the ratio of the Rating (1=low 6=high) of Sudan in 2006 to that in 2007?
Provide a succinct answer. 1. What is the ratio of the Rating (1=low 6=high) in East Asia (all income levels) in 2006 to that in 2008?
Your answer should be very brief. 0.98. What is the ratio of the Rating (1=low 6=high) in Guinea in 2006 to that in 2008?
Your answer should be very brief. 0.83. What is the ratio of the Rating (1=low 6=high) in Sudan in 2006 to that in 2008?
Give a very brief answer. 1. What is the ratio of the Rating (1=low 6=high) in East Asia (all income levels) in 2006 to that in 2009?
Provide a succinct answer. 0.97. What is the ratio of the Rating (1=low 6=high) in Sudan in 2006 to that in 2009?
Make the answer very short. 1. What is the ratio of the Rating (1=low 6=high) in East Asia (all income levels) in 2006 to that in 2010?
Offer a very short reply. 0.95. What is the ratio of the Rating (1=low 6=high) of Guinea in 2006 to that in 2010?
Ensure brevity in your answer.  0.83. What is the ratio of the Rating (1=low 6=high) in Sudan in 2006 to that in 2010?
Provide a succinct answer. 1. What is the ratio of the Rating (1=low 6=high) of East Asia (all income levels) in 2006 to that in 2011?
Give a very brief answer. 0.99. What is the ratio of the Rating (1=low 6=high) in East Asia (all income levels) in 2006 to that in 2012?
Make the answer very short. 1.01. What is the ratio of the Rating (1=low 6=high) of Guinea in 2006 to that in 2012?
Offer a terse response. 0.83. What is the ratio of the Rating (1=low 6=high) of Sudan in 2006 to that in 2012?
Your answer should be compact. 0.8. What is the ratio of the Rating (1=low 6=high) in East Asia (all income levels) in 2007 to that in 2008?
Your answer should be very brief. 0.97. What is the ratio of the Rating (1=low 6=high) in Bangladesh in 2007 to that in 2008?
Keep it short and to the point. 1. What is the ratio of the Rating (1=low 6=high) in East Asia (all income levels) in 2007 to that in 2009?
Offer a very short reply. 0.96. What is the ratio of the Rating (1=low 6=high) of Sudan in 2007 to that in 2009?
Your response must be concise. 1. What is the ratio of the Rating (1=low 6=high) in East Asia (all income levels) in 2007 to that in 2010?
Offer a very short reply. 0.95. What is the ratio of the Rating (1=low 6=high) of Bangladesh in 2007 to that in 2010?
Keep it short and to the point. 1. What is the ratio of the Rating (1=low 6=high) of Guinea in 2007 to that in 2010?
Ensure brevity in your answer.  1. What is the ratio of the Rating (1=low 6=high) of East Asia (all income levels) in 2007 to that in 2011?
Provide a short and direct response. 0.99. What is the ratio of the Rating (1=low 6=high) in Sudan in 2007 to that in 2011?
Offer a very short reply. 0.8. What is the ratio of the Rating (1=low 6=high) of Guinea in 2007 to that in 2012?
Make the answer very short. 1. What is the ratio of the Rating (1=low 6=high) in East Asia (all income levels) in 2008 to that in 2009?
Keep it short and to the point. 0.99. What is the ratio of the Rating (1=low 6=high) of Sudan in 2008 to that in 2009?
Ensure brevity in your answer.  1. What is the ratio of the Rating (1=low 6=high) in East Asia (all income levels) in 2008 to that in 2010?
Your response must be concise. 0.97. What is the ratio of the Rating (1=low 6=high) of Bangladesh in 2008 to that in 2010?
Your answer should be compact. 1. What is the ratio of the Rating (1=low 6=high) of Sudan in 2008 to that in 2010?
Your answer should be compact. 1. What is the ratio of the Rating (1=low 6=high) in East Asia (all income levels) in 2008 to that in 2011?
Give a very brief answer. 1.01. What is the ratio of the Rating (1=low 6=high) of Sudan in 2008 to that in 2011?
Offer a terse response. 0.8. What is the ratio of the Rating (1=low 6=high) of East Asia (all income levels) in 2008 to that in 2012?
Provide a short and direct response. 1.03. What is the ratio of the Rating (1=low 6=high) in Guinea in 2008 to that in 2012?
Your response must be concise. 1. What is the ratio of the Rating (1=low 6=high) of Sudan in 2008 to that in 2012?
Offer a terse response. 0.8. What is the ratio of the Rating (1=low 6=high) in East Asia (all income levels) in 2009 to that in 2010?
Offer a terse response. 0.99. What is the ratio of the Rating (1=low 6=high) of Guinea in 2009 to that in 2010?
Your response must be concise. 1. What is the ratio of the Rating (1=low 6=high) in Sudan in 2009 to that in 2010?
Ensure brevity in your answer.  1. What is the ratio of the Rating (1=low 6=high) in East Asia (all income levels) in 2009 to that in 2011?
Provide a short and direct response. 1.03. What is the ratio of the Rating (1=low 6=high) in Guinea in 2009 to that in 2011?
Keep it short and to the point. 1. What is the ratio of the Rating (1=low 6=high) of East Asia (all income levels) in 2009 to that in 2012?
Ensure brevity in your answer.  1.05. What is the ratio of the Rating (1=low 6=high) of Guinea in 2009 to that in 2012?
Offer a terse response. 1. What is the ratio of the Rating (1=low 6=high) of Sudan in 2009 to that in 2012?
Give a very brief answer. 0.8. What is the ratio of the Rating (1=low 6=high) of East Asia (all income levels) in 2010 to that in 2011?
Your answer should be compact. 1.04. What is the ratio of the Rating (1=low 6=high) in Bangladesh in 2010 to that in 2011?
Ensure brevity in your answer.  1. What is the ratio of the Rating (1=low 6=high) in East Asia (all income levels) in 2010 to that in 2012?
Make the answer very short. 1.06. What is the ratio of the Rating (1=low 6=high) in Sudan in 2010 to that in 2012?
Offer a very short reply. 0.8. What is the ratio of the Rating (1=low 6=high) of East Asia (all income levels) in 2011 to that in 2012?
Your response must be concise. 1.02. What is the ratio of the Rating (1=low 6=high) of Bangladesh in 2011 to that in 2012?
Make the answer very short. 1. What is the difference between the highest and the second highest Rating (1=low 6=high) in East Asia (all income levels)?
Offer a terse response. 0.05. What is the difference between the highest and the second highest Rating (1=low 6=high) of Guinea?
Keep it short and to the point. 0. What is the difference between the highest and the lowest Rating (1=low 6=high) in East Asia (all income levels)?
Keep it short and to the point. 0.19. 